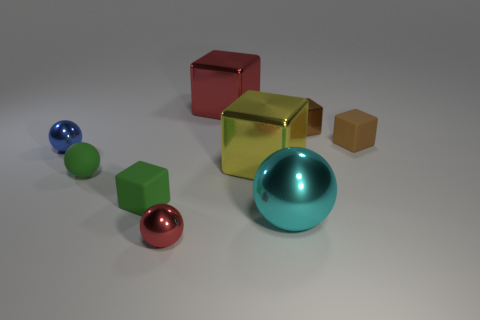Subtract all tiny green blocks. How many blocks are left? 4 Subtract all green blocks. How many blocks are left? 4 Subtract all cyan blocks. Subtract all blue cylinders. How many blocks are left? 5 Subtract all spheres. How many objects are left? 5 Add 5 large metal blocks. How many large metal blocks are left? 7 Add 2 large spheres. How many large spheres exist? 3 Subtract 0 brown cylinders. How many objects are left? 9 Subtract all tiny purple blocks. Subtract all blue balls. How many objects are left? 8 